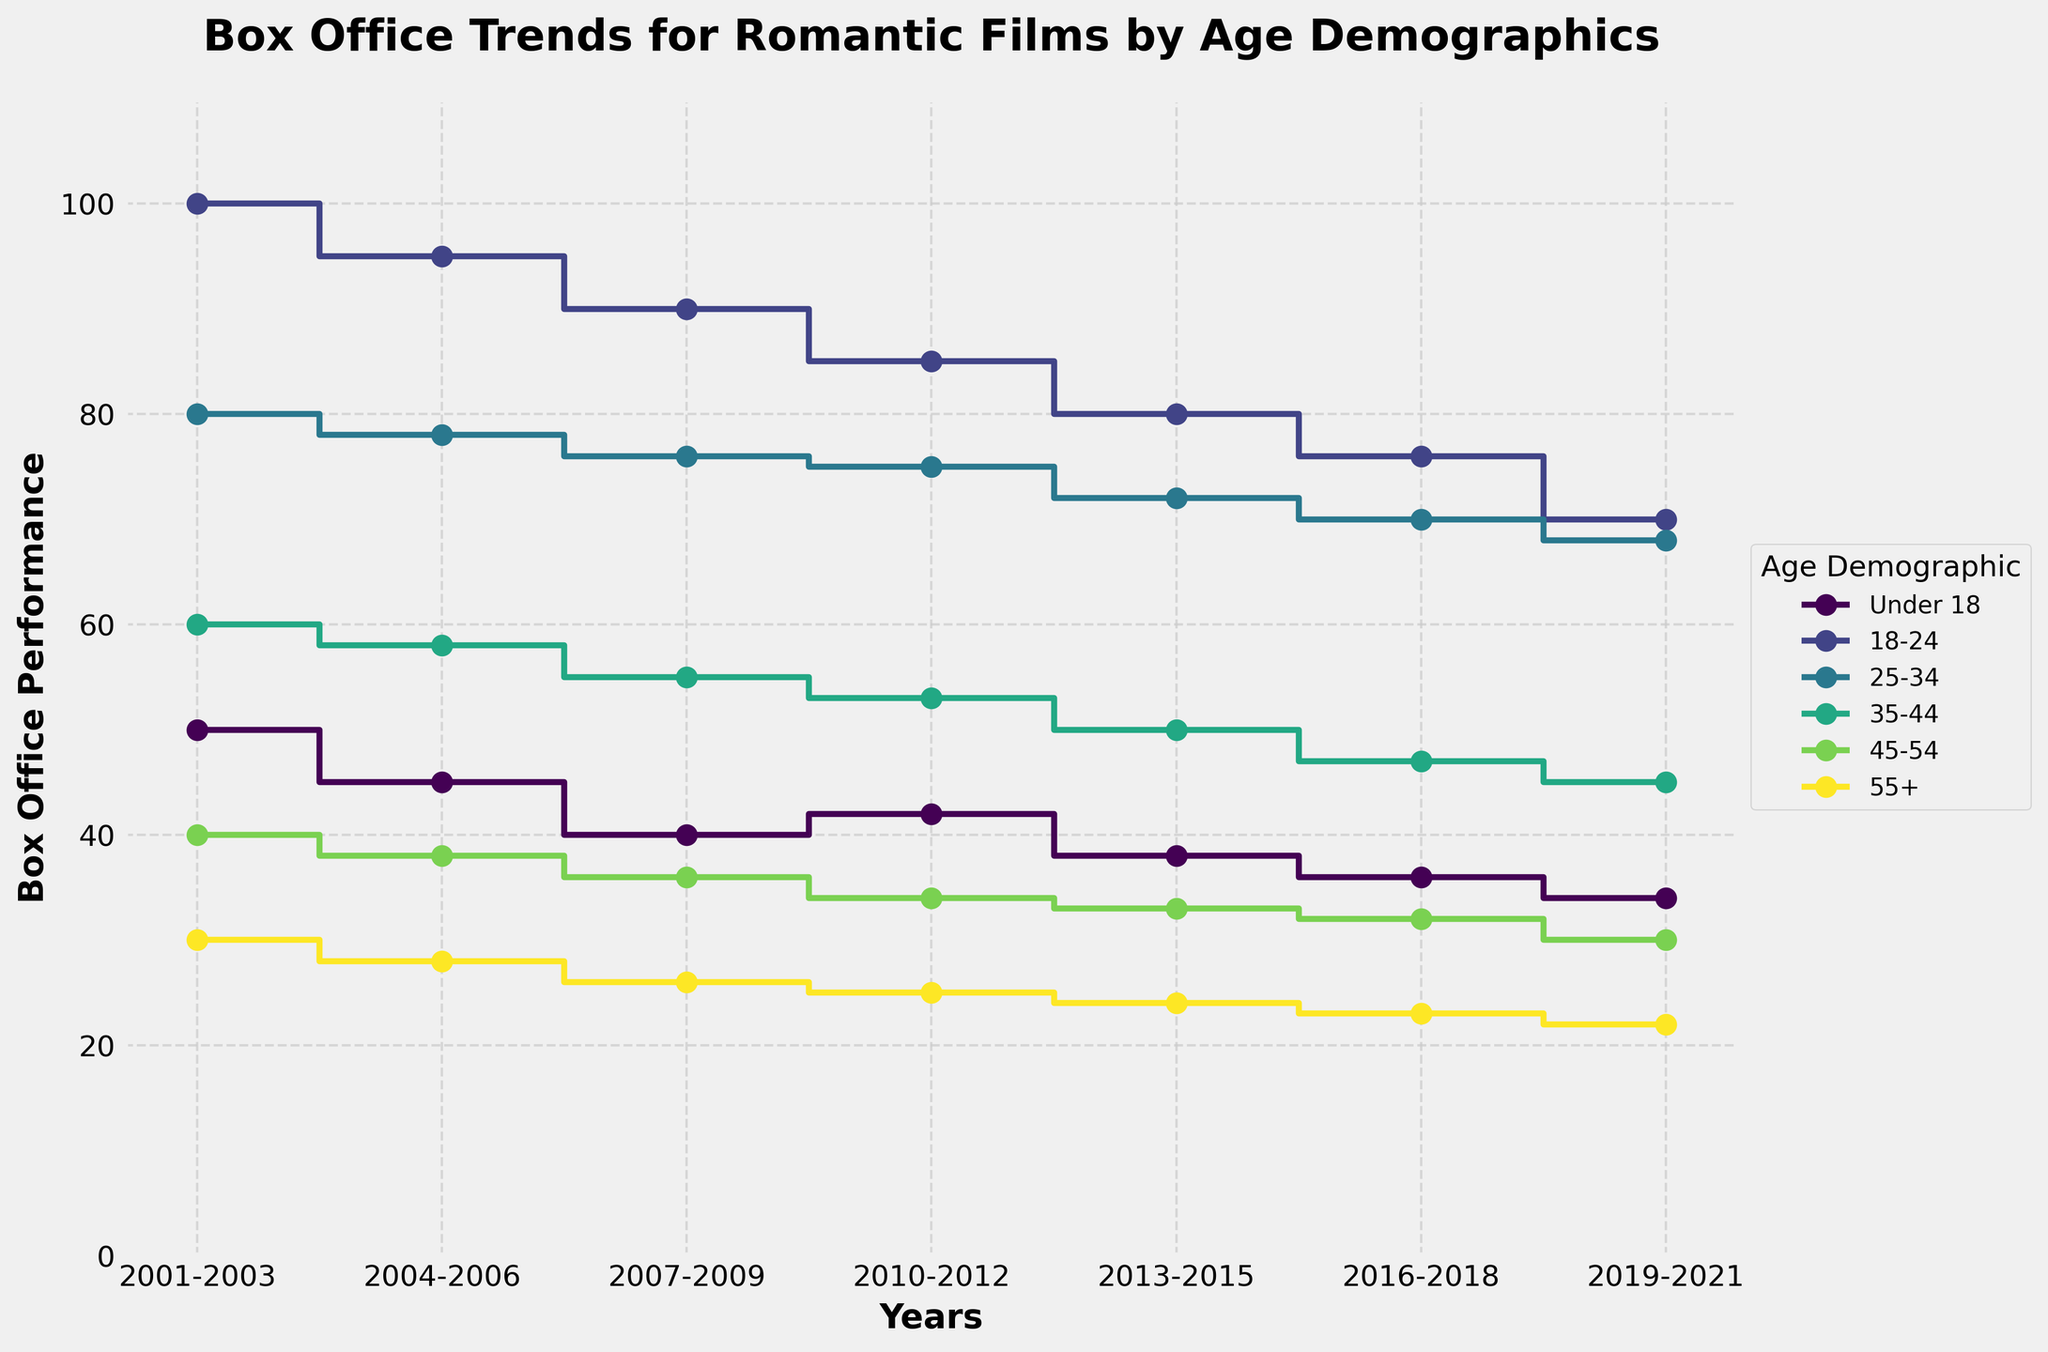what is the title of the plot? The title of the plot is usually displayed prominently at the top and indicates the subject of the graph. Here, it is clearly visible.
Answer: Box Office Trends for Romantic Films by Age Demographics How many age demographics are represented in the plot? The plot shows different lines for each age demographic, and they can be identified by the legend displayed on the plot. Count the unique labels in the legend.
Answer: 6 During which years did the "Under 18" demographic show the highest box office performance? Identify the "Under 18" demographic line on the plot and look for the years with the highest point on the Y-axis.
Answer: 2001-2003 Between 2013-2015 and 2019-2021, which age demographic's box office trend decreased the most? Observe the difference in box office values between 2013-2015 and 2019-2021 for each age demographic. The one with the greatest decrease shows the largest negative trend.
Answer: 18-24 What's the trend in box office performance for the 55+ demographic from 2001-2003 to 2019-2021? Follow the line corresponding to the 55+ demographic from 2001 to 2021. Note whether the line is increasing, decreasing, or stable over time.
Answer: Decreasing Which age demographic showed the smallest variation in box office performance over the years? Analyze the lines and look for the one with the least change in values (least steep slopes) between the time periods.
Answer: 55+ What is the average box office performance for the 25-34 demographic over the years? Sum the box office performance values for the 25-34 demographic across all periods and divide by the number of periods (7).
Answer: 74 Between 2004-2006 and 2007-2009, how did the box office performance change for the 18-24 demographic? Examine the plot to see the box office performance values for the 18-24 demographic in 2004-2006 and 2007-2009. Subtract the later value from the earlier one.
Answer: Decreased by 5 In the most recent period (2019-2021), which age demographic had the lowest box office performance? Look at the values in the most recent period (2019-2021) and identify the demographic with the lowest value.
Answer: 55+ Which two age demographics had equal box office performance during 2004-2006? Compare the box office values of all age demographics in the period 2004-2006 to identify any that are equal.
Answer: 35-44 and 45-54 